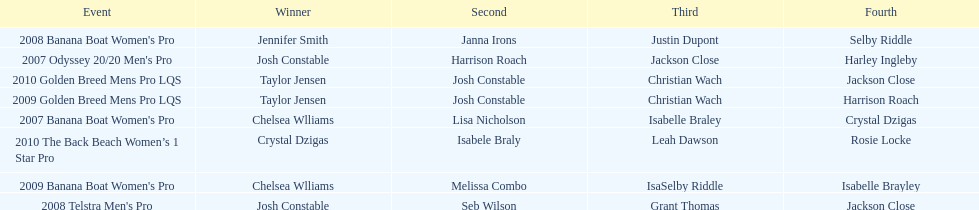In what event did chelsea williams win her first title? 2007 Banana Boat Women's Pro. 